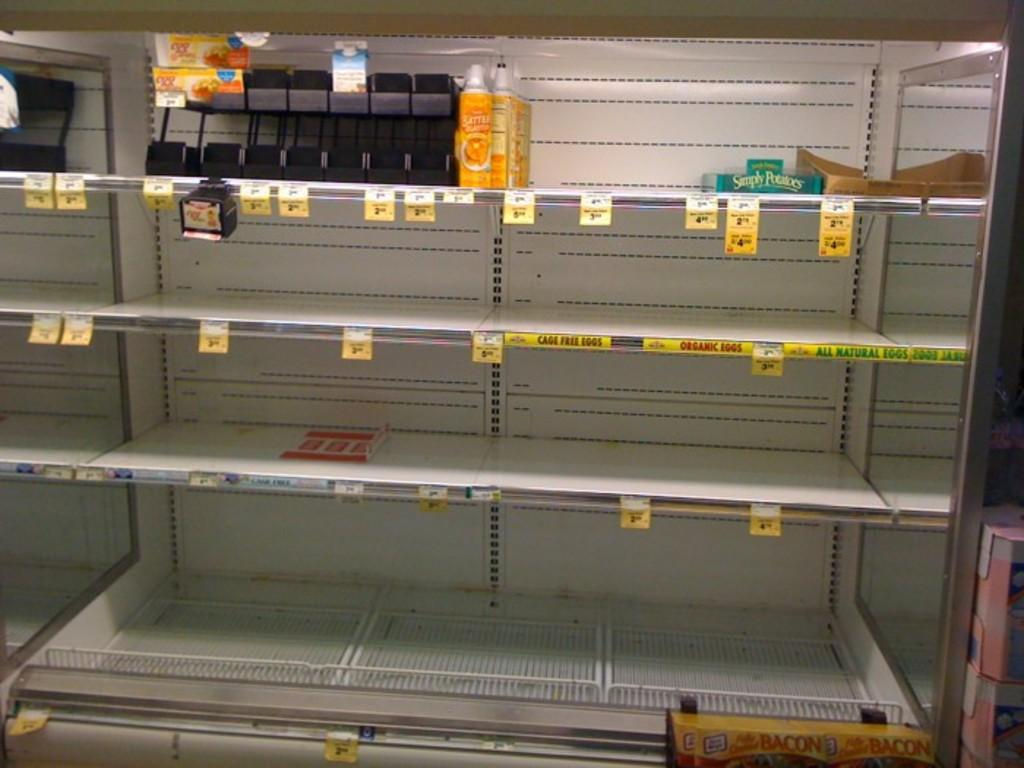What type of storage unit is depicted in the image? There are racks in the image, which are likely part of a refrigerator. What can be seen on top of the racks in the image? There are bottles visible on the top of the image. What role does the minister play in the image? There is no minister present in the image; it only features racks and bottles. 